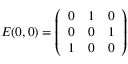<formula> <loc_0><loc_0><loc_500><loc_500>E ( 0 , 0 ) = \left ( \begin{array} { c c c } { 0 } & { 1 } & { 0 } \\ { 0 } & { 0 } & { 1 } \\ { 1 } & { 0 } & { 0 } \end{array} \right )</formula> 